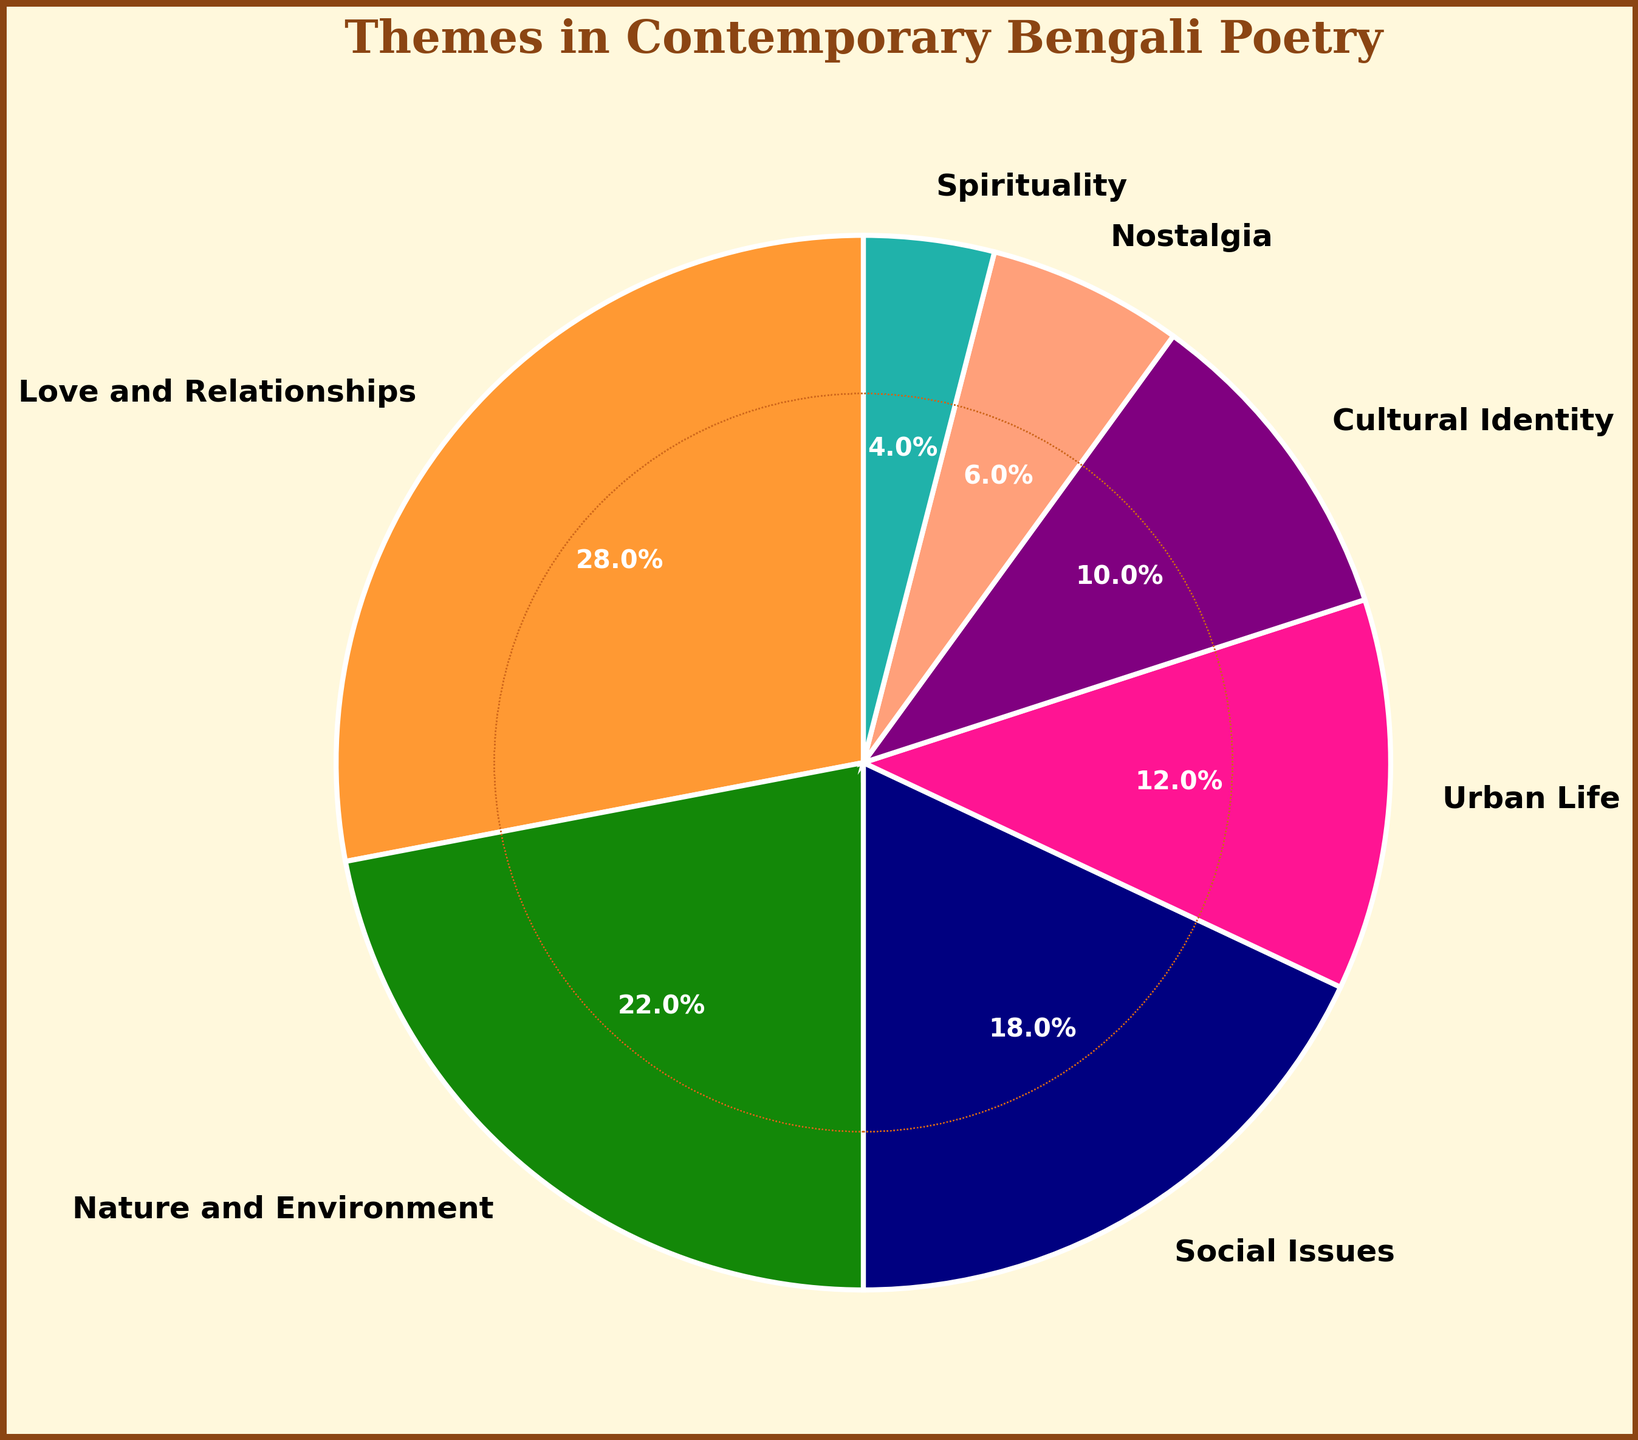What percentage of contemporary Bengali poetry themes is dedicated to both Love and Relationships and Nature and Environment? Sum the percentages of Love and Relationships (28%) and Nature and Environment (22%). 28 + 22 = 50
Answer: 50% Which theme is more prevalent: Cultural Identity or Urban Life, and by how much? Compare the percentages of Urban Life (12%) and Cultural Identity (10%), then calculate the difference. 12 - 10 = 2
Answer: Urban Life by 2% What is the total percentage of themes focused on Social Issues, Cultural Identity, and Nostalgia combined? Sum the percentages of Social Issues (18%), Cultural Identity (10%), and Nostalgia (6%). 18 + 10 + 6 = 34
Answer: 34% Is the proportion of themes related to Social Issues greater than or less than the sum of Spirituality and Nostalgia? Compare the percentage of Social Issues (18%) with the sum of Spirituality (4%) and Nostalgia (6%). 4 + 6 = 10, and 18 is greater than 10
Answer: Greater than Which theme occupies the smallest percentage in the pie chart, and what is the percentage? Identify the theme with the smallest percentage by comparing all the values. Spirituality has the smallest percentage, 4%
Answer: Spirituality, 4% How much more percentage is devoted to Love and Relationships compared to Social Issues? Subtract the percentage of Social Issues (18%) from Love and Relationships (28%). 28 - 18 = 10
Answer: 10% What is the difference between the most prevalent theme and the least prevalent theme? Subtract the least prevalent theme percentage (Spirituality, 4%) from the most prevalent theme percentage (Love and Relationships, 28%). 28 - 4 = 24
Answer: 24% If you combine the percentages of Urban Life, Cultural Identity, and Spirituality, does it exceed the percentage of Love and Relationships? Sum the percentages of Urban Life (12%), Cultural Identity (10%), and Spirituality (4%) and then compare with Love and Relationships (28%). 12 + 10 + 4 = 26, and 26 is less than 28
Answer: No, it does not exceed 